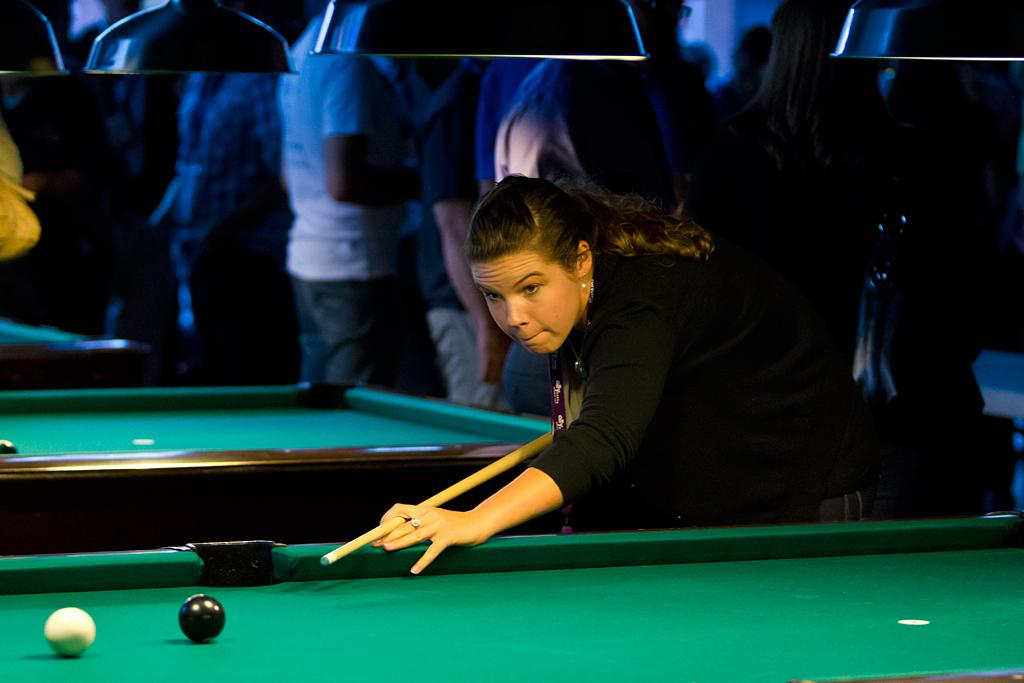Who is present in the image? There is a woman in the image. What is the woman doing or near in the image? The woman is near a snooker table. How many balls are on the snooker table? There are two balls on the snooker table. What object is used to hit the balls in the game of snooker? There is a stick (presumably a snooker cue) in the image. Can you describe the background of the image? There are people visible in the background of the image. What type of berry is being dropped on the snooker table in the image? There is no berry present in the image, and no one is dropping anything on the snooker table. 